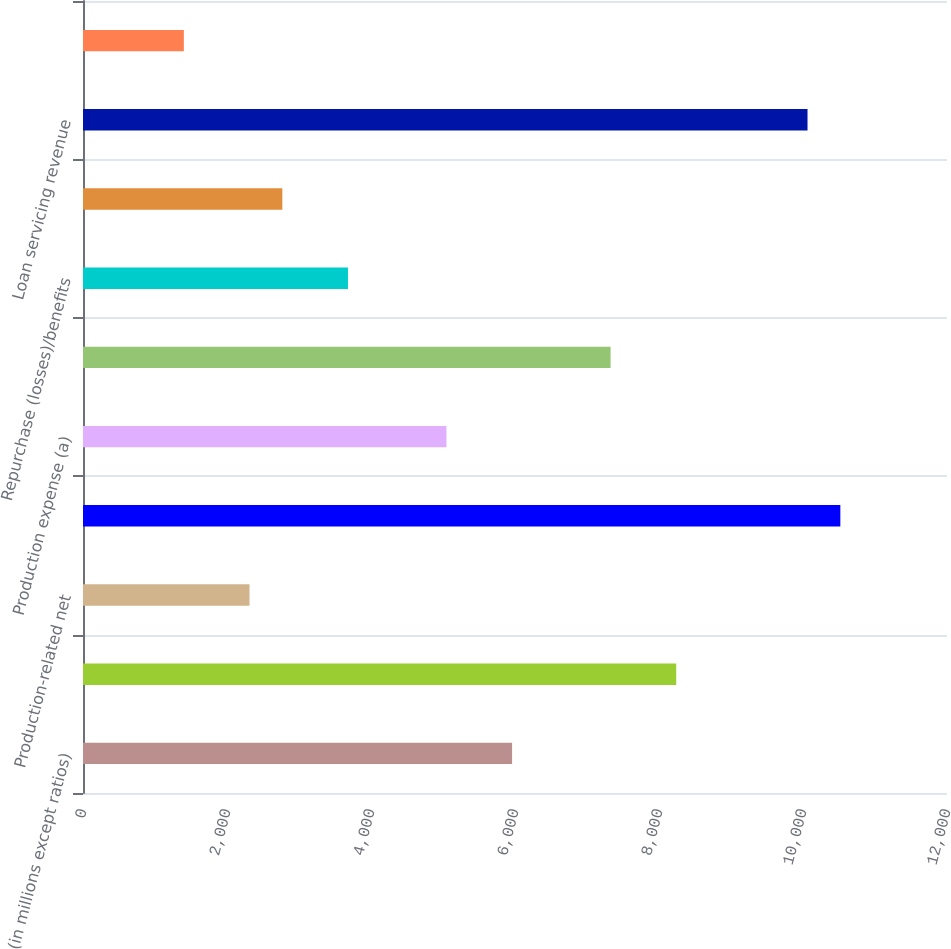Convert chart to OTSL. <chart><loc_0><loc_0><loc_500><loc_500><bar_chart><fcel>(in millions except ratios)<fcel>Production revenue<fcel>Production-related net<fcel>Production-related revenue<fcel>Production expense (a)<fcel>Income excluding repurchase<fcel>Repurchase (losses)/benefits<fcel>Income before income tax<fcel>Loan servicing revenue<fcel>Servicing-related net interest<nl><fcel>5959.7<fcel>8239.2<fcel>2312.5<fcel>10518.7<fcel>5047.9<fcel>7327.4<fcel>3680.2<fcel>2768.4<fcel>10062.8<fcel>1400.7<nl></chart> 